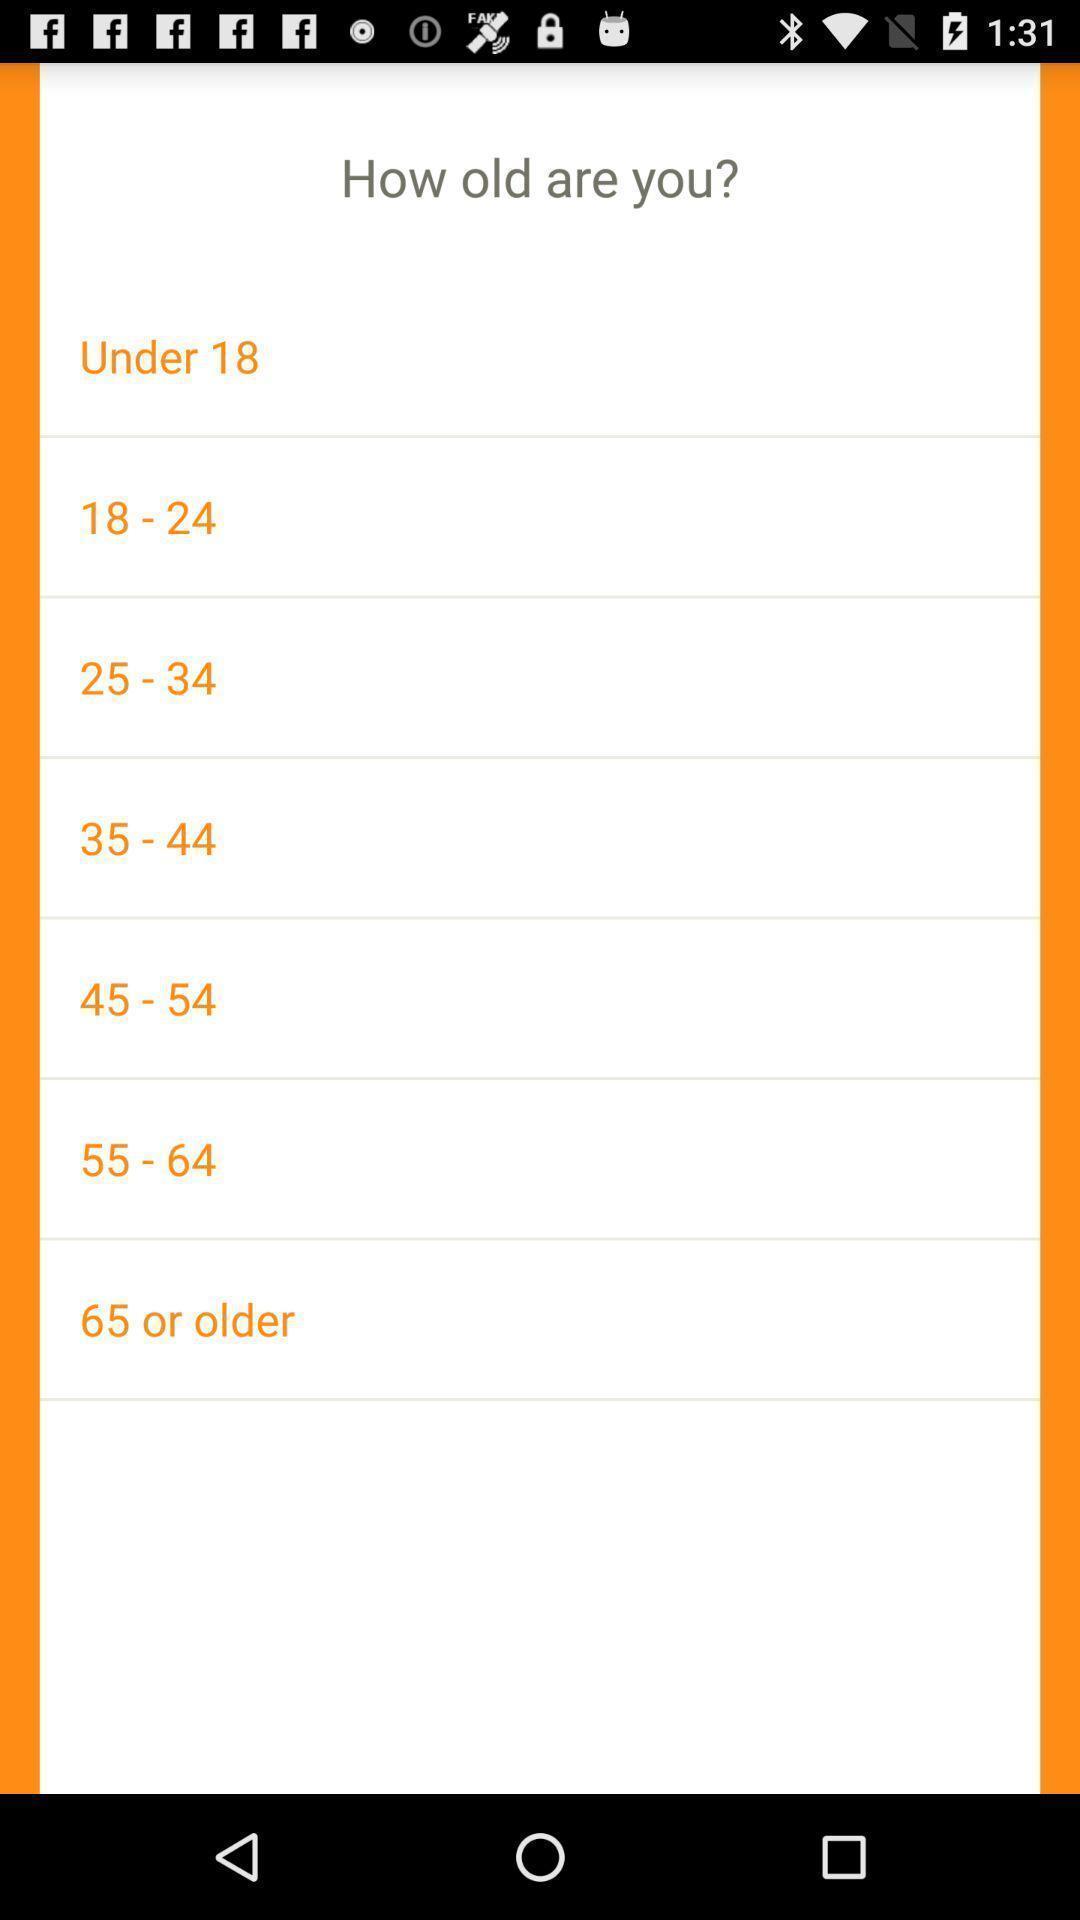Describe the visual elements of this screenshot. Screen displaying to select the age. 